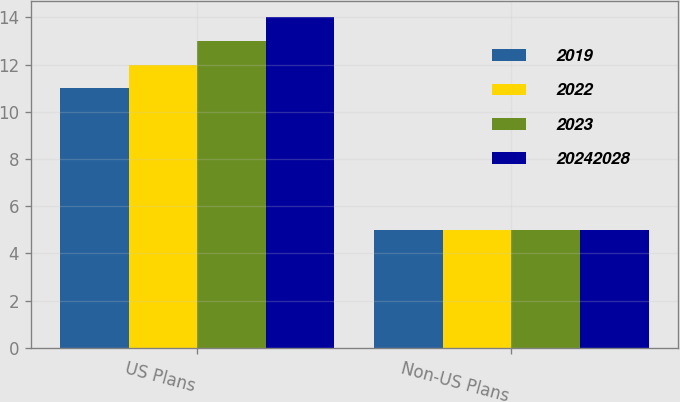<chart> <loc_0><loc_0><loc_500><loc_500><stacked_bar_chart><ecel><fcel>US Plans<fcel>Non-US Plans<nl><fcel>2019<fcel>11<fcel>5<nl><fcel>2022<fcel>12<fcel>5<nl><fcel>2023<fcel>13<fcel>5<nl><fcel>2.0242e+07<fcel>14<fcel>5<nl></chart> 